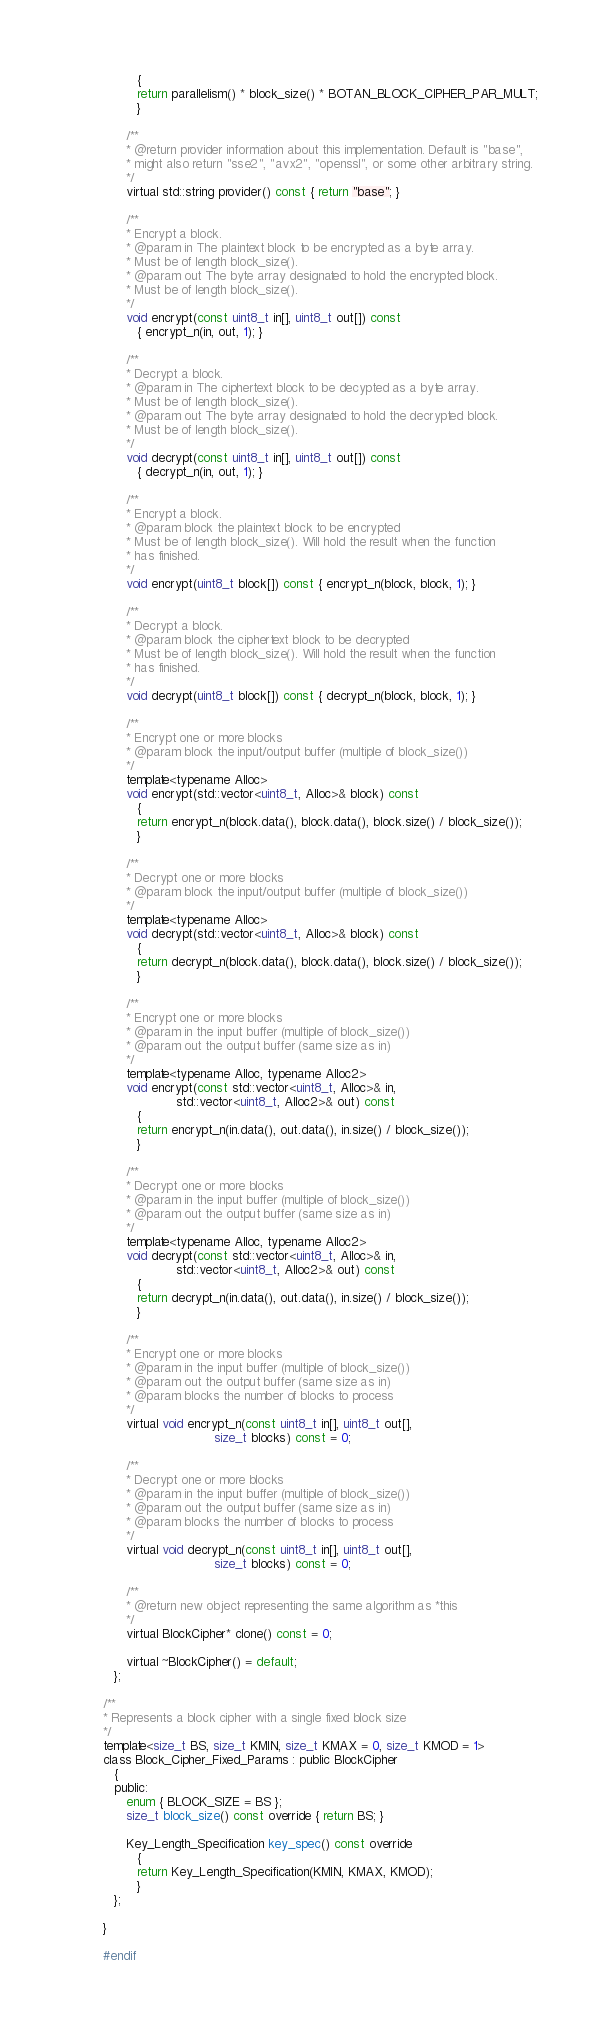<code> <loc_0><loc_0><loc_500><loc_500><_C_>         {
         return parallelism() * block_size() * BOTAN_BLOCK_CIPHER_PAR_MULT;
         }

      /**
      * @return provider information about this implementation. Default is "base",
      * might also return "sse2", "avx2", "openssl", or some other arbitrary string.
      */
      virtual std::string provider() const { return "base"; }

      /**
      * Encrypt a block.
      * @param in The plaintext block to be encrypted as a byte array.
      * Must be of length block_size().
      * @param out The byte array designated to hold the encrypted block.
      * Must be of length block_size().
      */
      void encrypt(const uint8_t in[], uint8_t out[]) const
         { encrypt_n(in, out, 1); }

      /**
      * Decrypt a block.
      * @param in The ciphertext block to be decypted as a byte array.
      * Must be of length block_size().
      * @param out The byte array designated to hold the decrypted block.
      * Must be of length block_size().
      */
      void decrypt(const uint8_t in[], uint8_t out[]) const
         { decrypt_n(in, out, 1); }

      /**
      * Encrypt a block.
      * @param block the plaintext block to be encrypted
      * Must be of length block_size(). Will hold the result when the function
      * has finished.
      */
      void encrypt(uint8_t block[]) const { encrypt_n(block, block, 1); }

      /**
      * Decrypt a block.
      * @param block the ciphertext block to be decrypted
      * Must be of length block_size(). Will hold the result when the function
      * has finished.
      */
      void decrypt(uint8_t block[]) const { decrypt_n(block, block, 1); }

      /**
      * Encrypt one or more blocks
      * @param block the input/output buffer (multiple of block_size())
      */
      template<typename Alloc>
      void encrypt(std::vector<uint8_t, Alloc>& block) const
         {
         return encrypt_n(block.data(), block.data(), block.size() / block_size());
         }

      /**
      * Decrypt one or more blocks
      * @param block the input/output buffer (multiple of block_size())
      */
      template<typename Alloc>
      void decrypt(std::vector<uint8_t, Alloc>& block) const
         {
         return decrypt_n(block.data(), block.data(), block.size() / block_size());
         }

      /**
      * Encrypt one or more blocks
      * @param in the input buffer (multiple of block_size())
      * @param out the output buffer (same size as in)
      */
      template<typename Alloc, typename Alloc2>
      void encrypt(const std::vector<uint8_t, Alloc>& in,
                   std::vector<uint8_t, Alloc2>& out) const
         {
         return encrypt_n(in.data(), out.data(), in.size() / block_size());
         }

      /**
      * Decrypt one or more blocks
      * @param in the input buffer (multiple of block_size())
      * @param out the output buffer (same size as in)
      */
      template<typename Alloc, typename Alloc2>
      void decrypt(const std::vector<uint8_t, Alloc>& in,
                   std::vector<uint8_t, Alloc2>& out) const
         {
         return decrypt_n(in.data(), out.data(), in.size() / block_size());
         }

      /**
      * Encrypt one or more blocks
      * @param in the input buffer (multiple of block_size())
      * @param out the output buffer (same size as in)
      * @param blocks the number of blocks to process
      */
      virtual void encrypt_n(const uint8_t in[], uint8_t out[],
                             size_t blocks) const = 0;

      /**
      * Decrypt one or more blocks
      * @param in the input buffer (multiple of block_size())
      * @param out the output buffer (same size as in)
      * @param blocks the number of blocks to process
      */
      virtual void decrypt_n(const uint8_t in[], uint8_t out[],
                             size_t blocks) const = 0;

      /**
      * @return new object representing the same algorithm as *this
      */
      virtual BlockCipher* clone() const = 0;

      virtual ~BlockCipher() = default;
   };

/**
* Represents a block cipher with a single fixed block size
*/
template<size_t BS, size_t KMIN, size_t KMAX = 0, size_t KMOD = 1>
class Block_Cipher_Fixed_Params : public BlockCipher
   {
   public:
      enum { BLOCK_SIZE = BS };
      size_t block_size() const override { return BS; }

      Key_Length_Specification key_spec() const override
         {
         return Key_Length_Specification(KMIN, KMAX, KMOD);
         }
   };

}

#endif
</code> 